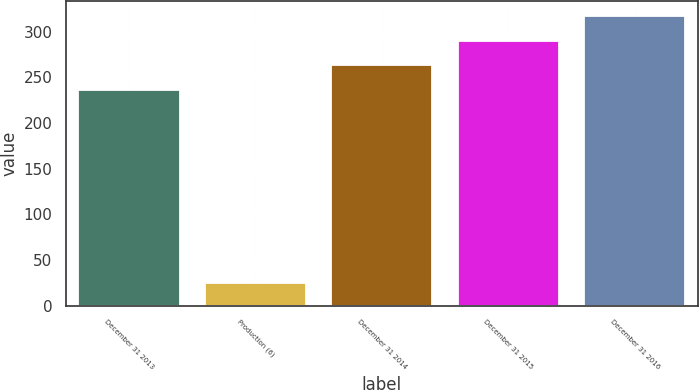Convert chart to OTSL. <chart><loc_0><loc_0><loc_500><loc_500><bar_chart><fcel>December 31 2013<fcel>Production (6)<fcel>December 31 2014<fcel>December 31 2015<fcel>December 31 2016<nl><fcel>236<fcel>25<fcel>263.1<fcel>290.2<fcel>317.3<nl></chart> 